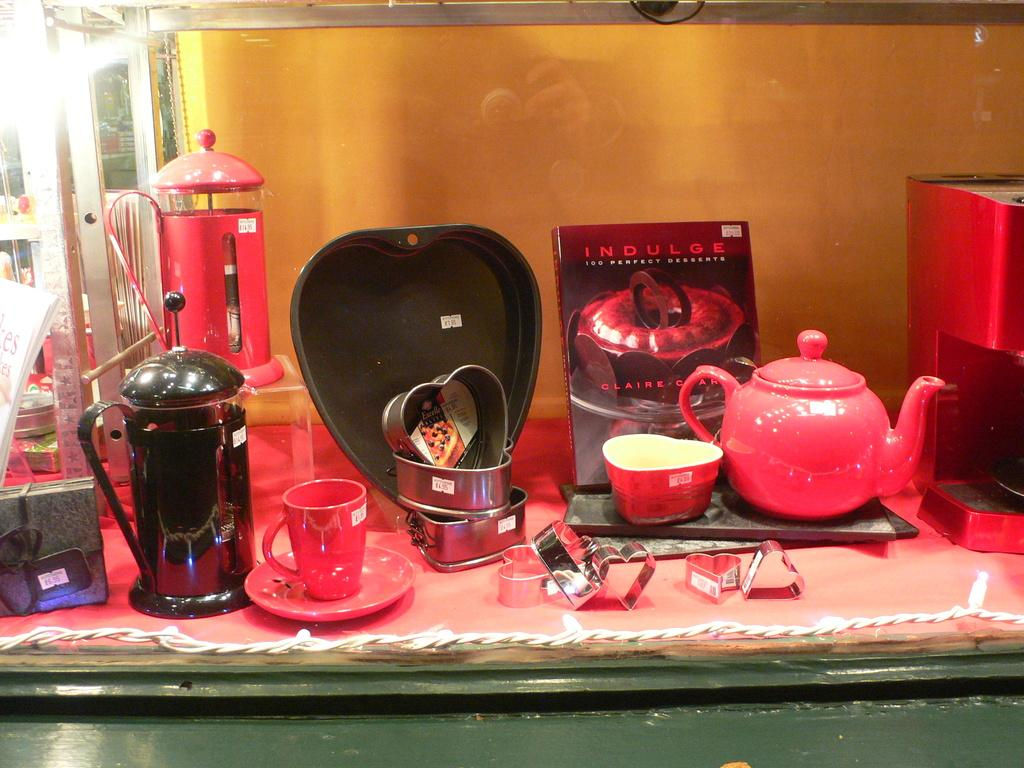<image>
Describe the image concisely. a book on a table that says indulge on it 